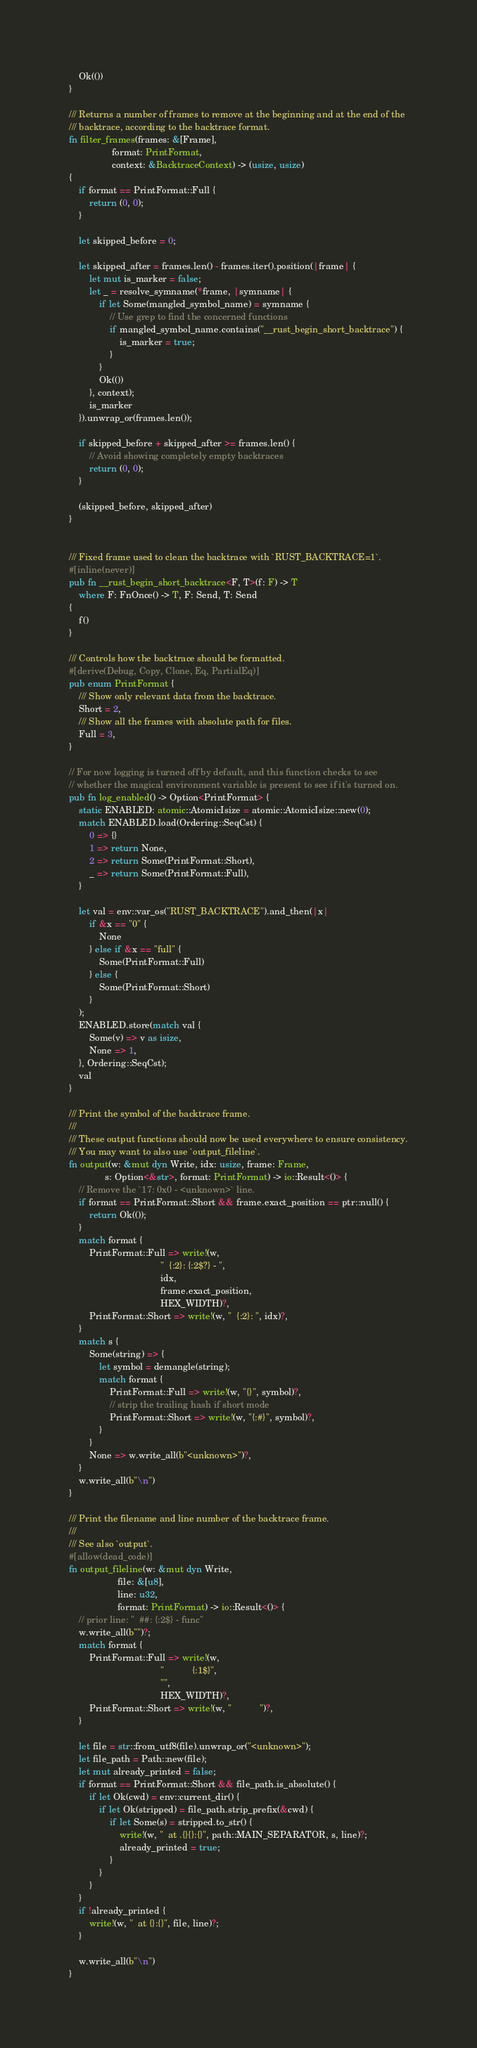Convert code to text. <code><loc_0><loc_0><loc_500><loc_500><_Rust_>
    Ok(())
}

/// Returns a number of frames to remove at the beginning and at the end of the
/// backtrace, according to the backtrace format.
fn filter_frames(frames: &[Frame],
                 format: PrintFormat,
                 context: &BacktraceContext) -> (usize, usize)
{
    if format == PrintFormat::Full {
        return (0, 0);
    }

    let skipped_before = 0;

    let skipped_after = frames.len() - frames.iter().position(|frame| {
        let mut is_marker = false;
        let _ = resolve_symname(*frame, |symname| {
            if let Some(mangled_symbol_name) = symname {
                // Use grep to find the concerned functions
                if mangled_symbol_name.contains("__rust_begin_short_backtrace") {
                    is_marker = true;
                }
            }
            Ok(())
        }, context);
        is_marker
    }).unwrap_or(frames.len());

    if skipped_before + skipped_after >= frames.len() {
        // Avoid showing completely empty backtraces
        return (0, 0);
    }

    (skipped_before, skipped_after)
}


/// Fixed frame used to clean the backtrace with `RUST_BACKTRACE=1`.
#[inline(never)]
pub fn __rust_begin_short_backtrace<F, T>(f: F) -> T
    where F: FnOnce() -> T, F: Send, T: Send
{
    f()
}

/// Controls how the backtrace should be formatted.
#[derive(Debug, Copy, Clone, Eq, PartialEq)]
pub enum PrintFormat {
    /// Show only relevant data from the backtrace.
    Short = 2,
    /// Show all the frames with absolute path for files.
    Full = 3,
}

// For now logging is turned off by default, and this function checks to see
// whether the magical environment variable is present to see if it's turned on.
pub fn log_enabled() -> Option<PrintFormat> {
    static ENABLED: atomic::AtomicIsize = atomic::AtomicIsize::new(0);
    match ENABLED.load(Ordering::SeqCst) {
        0 => {}
        1 => return None,
        2 => return Some(PrintFormat::Short),
        _ => return Some(PrintFormat::Full),
    }

    let val = env::var_os("RUST_BACKTRACE").and_then(|x|
        if &x == "0" {
            None
        } else if &x == "full" {
            Some(PrintFormat::Full)
        } else {
            Some(PrintFormat::Short)
        }
    );
    ENABLED.store(match val {
        Some(v) => v as isize,
        None => 1,
    }, Ordering::SeqCst);
    val
}

/// Print the symbol of the backtrace frame.
///
/// These output functions should now be used everywhere to ensure consistency.
/// You may want to also use `output_fileline`.
fn output(w: &mut dyn Write, idx: usize, frame: Frame,
              s: Option<&str>, format: PrintFormat) -> io::Result<()> {
    // Remove the `17: 0x0 - <unknown>` line.
    if format == PrintFormat::Short && frame.exact_position == ptr::null() {
        return Ok(());
    }
    match format {
        PrintFormat::Full => write!(w,
                                    "  {:2}: {:2$?} - ",
                                    idx,
                                    frame.exact_position,
                                    HEX_WIDTH)?,
        PrintFormat::Short => write!(w, "  {:2}: ", idx)?,
    }
    match s {
        Some(string) => {
            let symbol = demangle(string);
            match format {
                PrintFormat::Full => write!(w, "{}", symbol)?,
                // strip the trailing hash if short mode
                PrintFormat::Short => write!(w, "{:#}", symbol)?,
            }
        }
        None => w.write_all(b"<unknown>")?,
    }
    w.write_all(b"\n")
}

/// Print the filename and line number of the backtrace frame.
///
/// See also `output`.
#[allow(dead_code)]
fn output_fileline(w: &mut dyn Write,
                   file: &[u8],
                   line: u32,
                   format: PrintFormat) -> io::Result<()> {
    // prior line: "  ##: {:2$} - func"
    w.write_all(b"")?;
    match format {
        PrintFormat::Full => write!(w,
                                    "           {:1$}",
                                    "",
                                    HEX_WIDTH)?,
        PrintFormat::Short => write!(w, "           ")?,
    }

    let file = str::from_utf8(file).unwrap_or("<unknown>");
    let file_path = Path::new(file);
    let mut already_printed = false;
    if format == PrintFormat::Short && file_path.is_absolute() {
        if let Ok(cwd) = env::current_dir() {
            if let Ok(stripped) = file_path.strip_prefix(&cwd) {
                if let Some(s) = stripped.to_str() {
                    write!(w, "  at .{}{}:{}", path::MAIN_SEPARATOR, s, line)?;
                    already_printed = true;
                }
            }
        }
    }
    if !already_printed {
        write!(w, "  at {}:{}", file, line)?;
    }

    w.write_all(b"\n")
}

</code> 